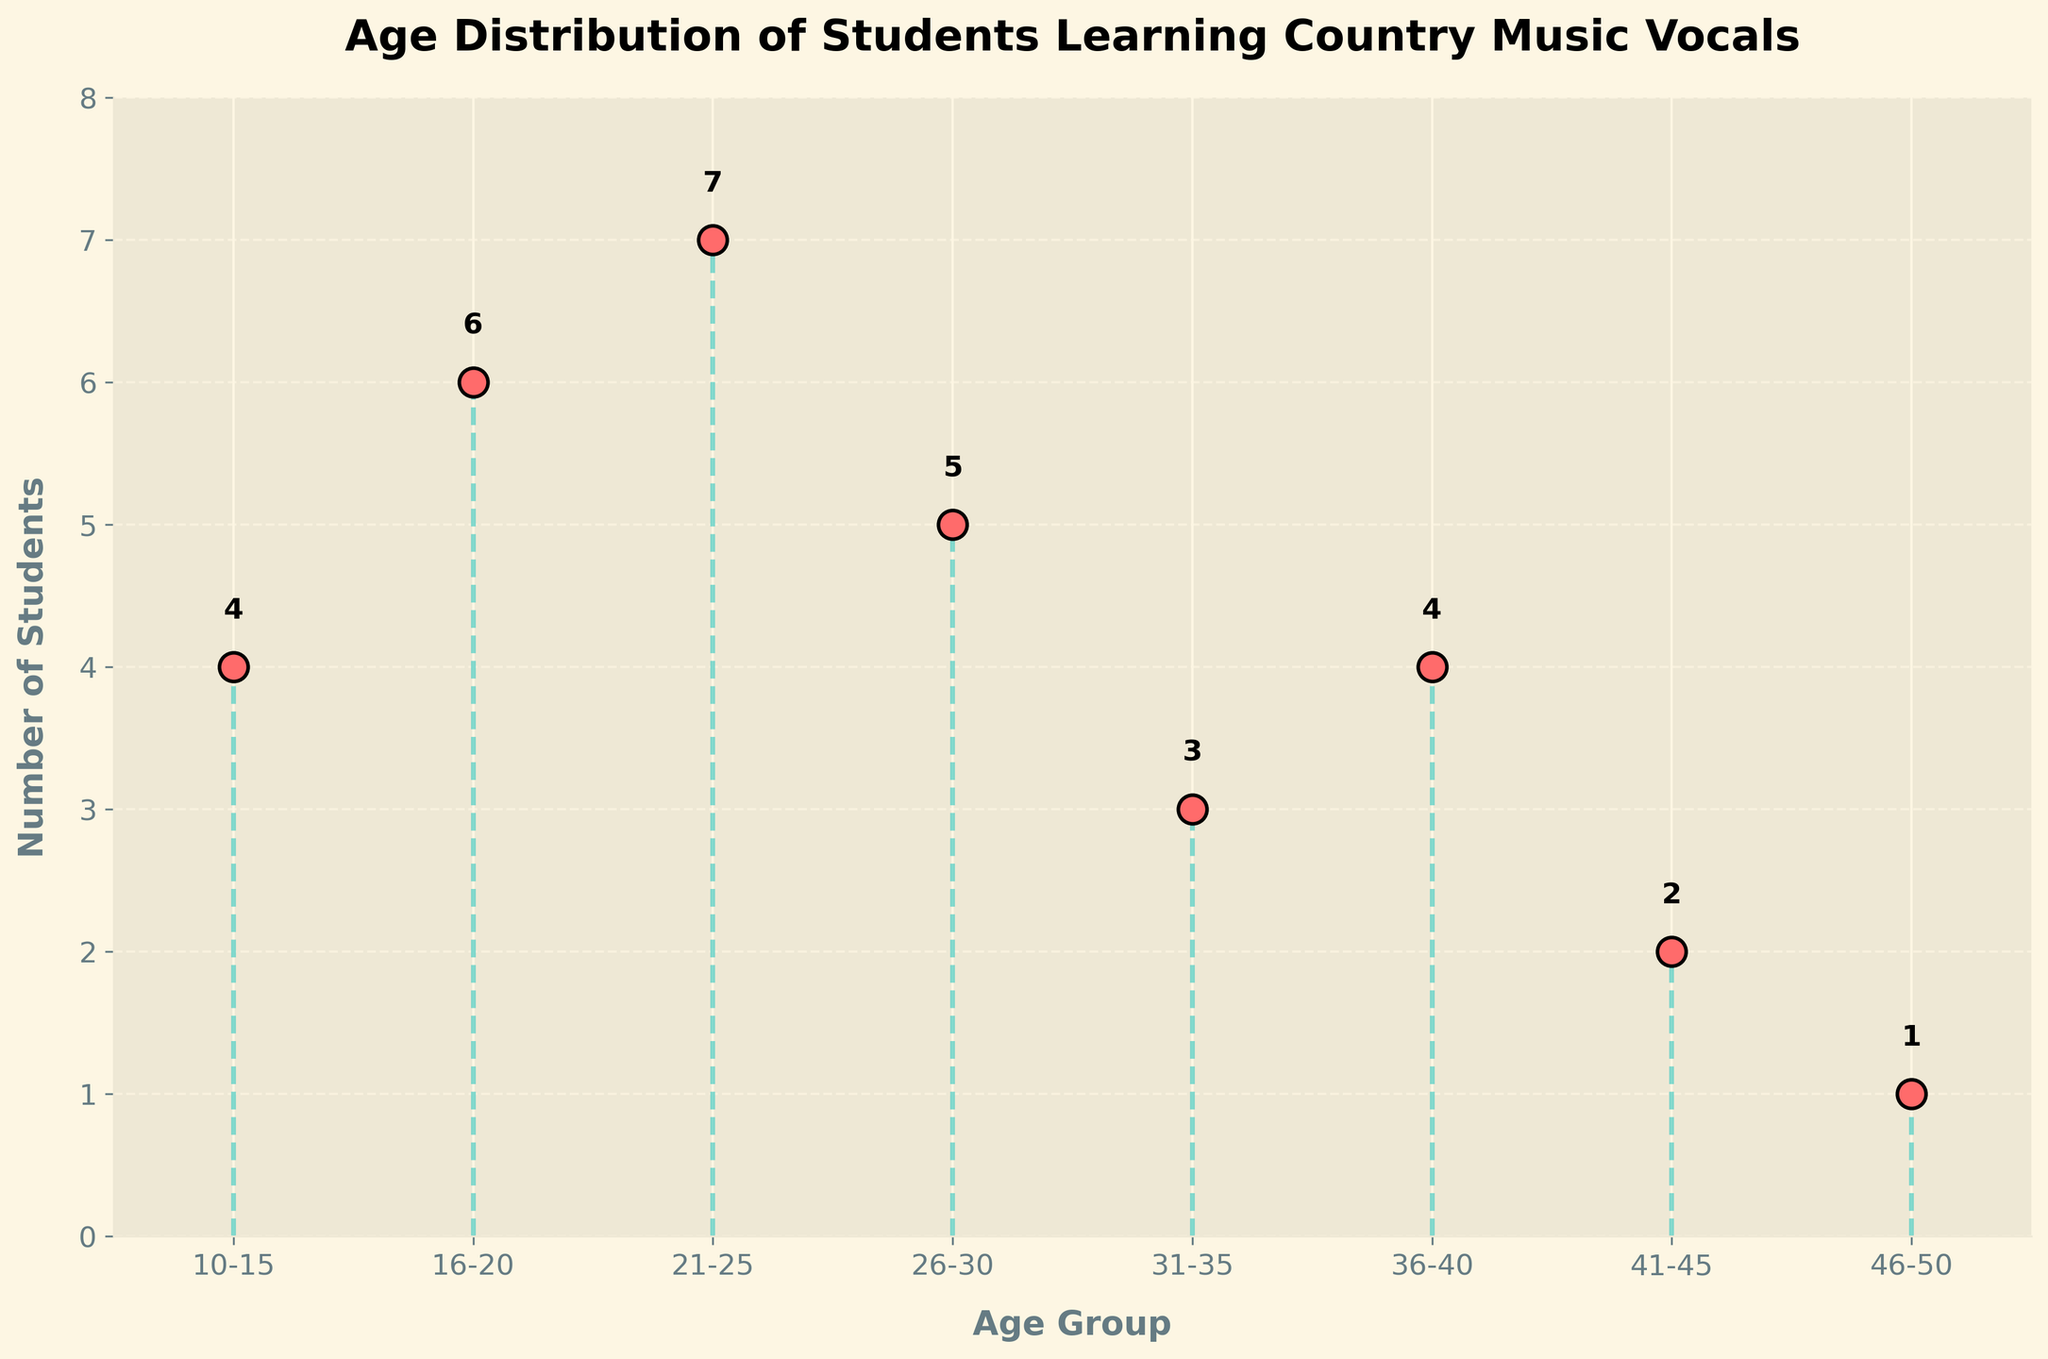What is the title of the figure? The title is usually located at the top of the figure, often in larger and bold font. In this case, it reads: "Age Distribution of Students Learning Country Music Vocals."
Answer: Age Distribution of Students Learning Country Music Vocals What does the x-axis represent? The x-axis label can be found directly below the x-axis line and tells us what kind of data are plotted on the horizontal axis. Here it is labeled as "Age Group."
Answer: Age Group How many students are in the 21-25 age group? The number of students for each age group is indicated by the height of the stem line and the number at the tip of each line. For the 21-25 age group, the stem line reaches up to 7 and the number "7" is annotated above the line.
Answer: 7 Which age group has the highest number of students? By visually inspecting the height of the stem lines, the 21-25 age group has the tallest line, annotated with "7," indicating the highest number of students.
Answer: 21-25 What is the total number of students represented in the figure? Sum the individual numbers of students for each age group: 4 (10-15) + 6 (16-20) + 7 (21-25) + 5 (26-30) + 3 (31-35) + 4 (36-40) + 2 (41-45) + 1 (46-50) = 32.
Answer: 32 Which age groups have an equal number of students? Look for age groups where the stem lines reach the same height and are annotated with the same number. Here, the 10-15 and 36-40 age groups both have 4 students each.
Answer: 10-15 and 36-40 How many age groups have fewer than 5 students? Count the age groups with stem lines annotated with numbers less than 5: 31-35 (3 students), 41-45 (2 students), and 46-50 (1 student), making it three age groups.
Answer: 3 What is the difference in the number of students between the 16-20 and 26-30 age groups? Subtract the number of students in the 26-30 age group from the number in the 16-20 age group: 6 (16-20) - 5 (26-30) = 1.
Answer: 1 Is the distribution of students heavily skewed towards any particular age group? The distribution is not heavily skewed towards any particular age group since the number of students varies across the age groups and doesn't show an extreme concentration in one. Though the 21-25 age group does have the highest number, it is followed closely by other groups.
Answer: No What is the average number of students across all age groups? Calculate the average by dividing the total number of students (32) by the number of age groups (8): 32 / 8 = 4.
Answer: 4 